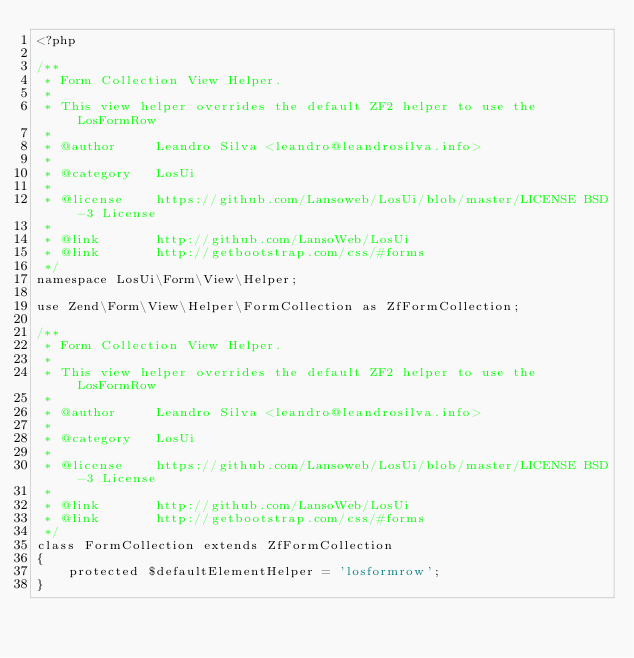<code> <loc_0><loc_0><loc_500><loc_500><_PHP_><?php

/**
 * Form Collection View Helper.
 *
 * This view helper overrides the default ZF2 helper to use the LosFormRow
 *
 * @author     Leandro Silva <leandro@leandrosilva.info>
 *
 * @category   LosUi
 *
 * @license    https://github.com/Lansoweb/LosUi/blob/master/LICENSE BSD-3 License
 *
 * @link       http://github.com/LansoWeb/LosUi
 * @link       http://getbootstrap.com/css/#forms
 */
namespace LosUi\Form\View\Helper;

use Zend\Form\View\Helper\FormCollection as ZfFormCollection;

/**
 * Form Collection View Helper.
 *
 * This view helper overrides the default ZF2 helper to use the LosFormRow
 *
 * @author     Leandro Silva <leandro@leandrosilva.info>
 *
 * @category   LosUi
 *
 * @license    https://github.com/Lansoweb/LosUi/blob/master/LICENSE BSD-3 License
 *
 * @link       http://github.com/LansoWeb/LosUi
 * @link       http://getbootstrap.com/css/#forms
 */
class FormCollection extends ZfFormCollection
{
    protected $defaultElementHelper = 'losformrow';
}
</code> 